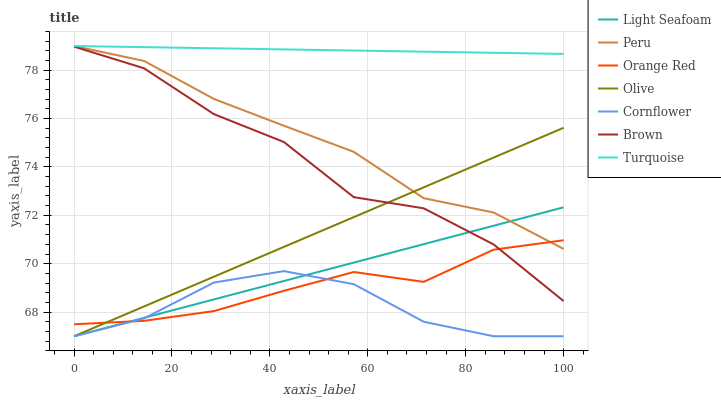Does Cornflower have the minimum area under the curve?
Answer yes or no. Yes. Does Turquoise have the maximum area under the curve?
Answer yes or no. Yes. Does Brown have the minimum area under the curve?
Answer yes or no. No. Does Brown have the maximum area under the curve?
Answer yes or no. No. Is Light Seafoam the smoothest?
Answer yes or no. Yes. Is Brown the roughest?
Answer yes or no. Yes. Is Turquoise the smoothest?
Answer yes or no. No. Is Turquoise the roughest?
Answer yes or no. No. Does Brown have the lowest value?
Answer yes or no. No. Does Brown have the highest value?
Answer yes or no. No. Is Brown less than Turquoise?
Answer yes or no. Yes. Is Turquoise greater than Olive?
Answer yes or no. Yes. Does Brown intersect Turquoise?
Answer yes or no. No. 